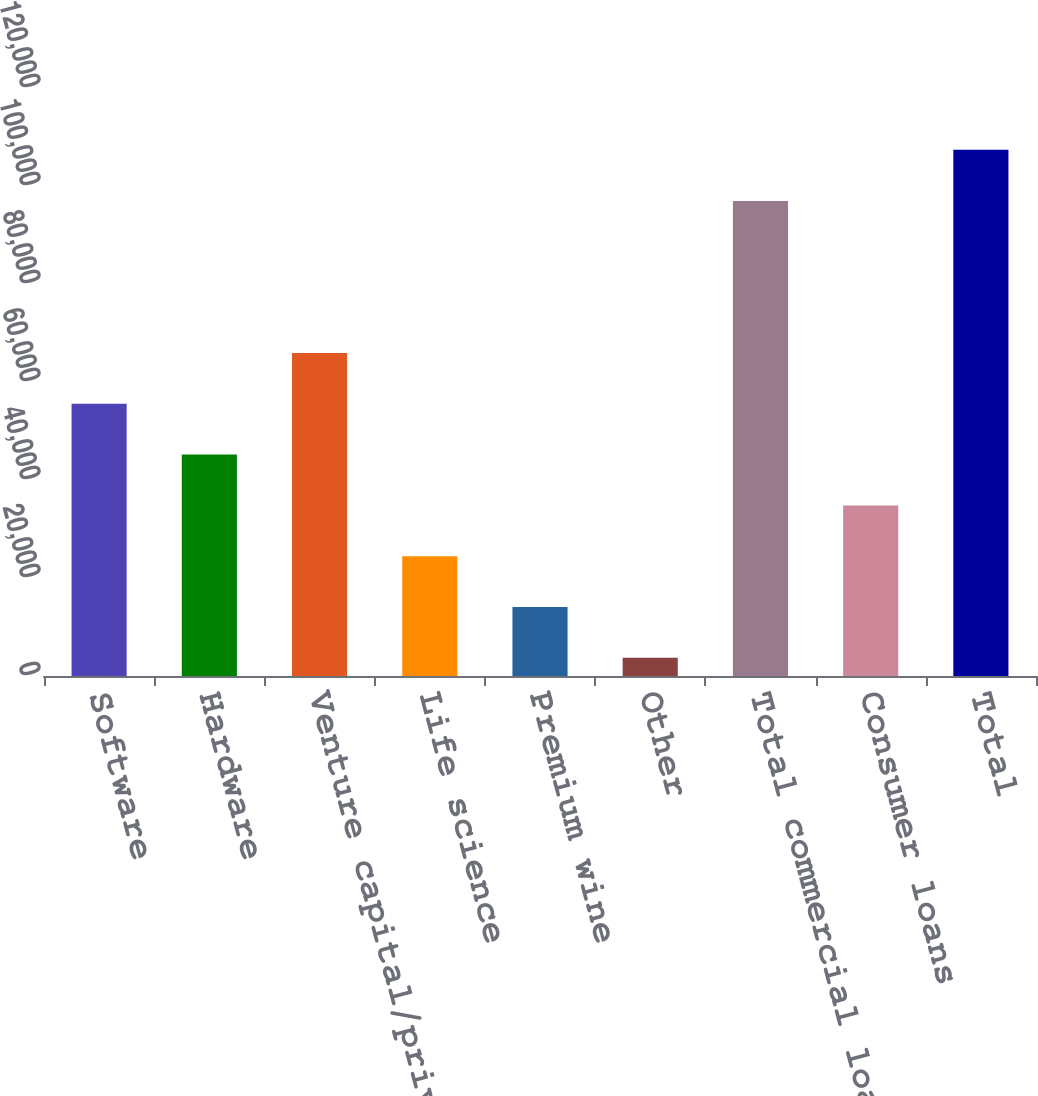Convert chart. <chart><loc_0><loc_0><loc_500><loc_500><bar_chart><fcel>Software<fcel>Hardware<fcel>Venture capital/private equity<fcel>Life science<fcel>Premium wine<fcel>Other<fcel>Total commercial loans<fcel>Consumer loans<fcel>Total<nl><fcel>55556.5<fcel>45188.6<fcel>65924.4<fcel>24452.8<fcel>14084.9<fcel>3717<fcel>96951<fcel>34820.7<fcel>107396<nl></chart> 